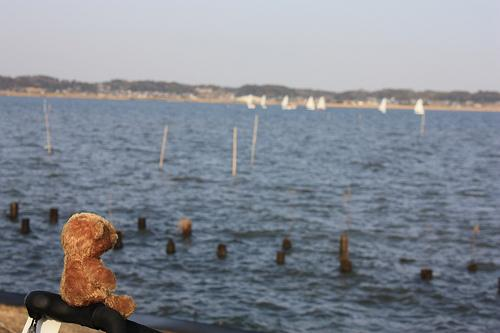Analyze the interaction between the teddy bear and its surroundings. The teddy bear is observing the water and sailboats, likely enjoying the serene and peaceful atmosphere while sitting securely on the bike handle. List the elements related to nature present in this image and explain their positions. There are row of trees beyond the beach located in the top-left region, mountains behind the water in the top-center region, and ripples in the water positioned in the center-right part of the image. What kind of boats are visible in the image, and whereabouts are they located? White sailboats are on the water in the top-right area of the image. Conduct a sentiment analysis of the image and describe the atmosphere. The image evokes a positive sentiment due to the peaceful setting of boats in the water, beautiful nature elements, and a cute teddy bear enjoying the view. Point out the object with the smallest size and describe its position. The smallest object is a small area of sandy beach at the bottom-left corner of the image. Count the number of pieces of wood sticking up from the water. There are 12 pieces of wood sticking up from the water. Provide a short description of the weather and overall atmosphere of the image. It is sunny outside with a hazy sky, mildly rough water, and clear blue-dark water, creating a peaceful and serene atmosphere. How many wooden poles are in the water and where are they located? There are wooden pegs and poles, totaling to 25 in the water, scattered throughout the image, mainly at the left and center regions. Identify the main object in the image and explain its position and color. A brown teddy bear is sitting on a bike handle at the left-top corner of the image, gazing toward the water. Notice the man wearing a bright green swimsuit and sunglasses while walking near the water's edge. This instruction describes a person (man) who is not mentioned in the list of objects, and the person is wearing distinctive clothing (bright green swimsuit, sunglasses) that also do not appear in the object list. Therefore, this instruction is misleading. Could you please point out the dolphins playfully leaping out of the water towards the left side of the image? This instruction uses an interrogative sentence and seeks information about dolphins, which are not mentioned in the list of objects in the image. Thus, the instruction is misleading. Can anyone observe the flock of seagulls hovering near a tourist who's attempting to feed them in the scene? This instruction uses an interrogative sentence form and brings up objects (flock of seagulls, tourist) not mentioned in the list of objects in the image. Consequently, it's misleading for viewers. Can you spot the vibrant pink seashell along the shoreline in the image? This instruction introduces a specific color (vibrant pink) and an object (seashell) that is not mentioned in the list of objects in the image. Therefore, it would be misleading for a viewer. It is interesting to note the intricate sandcastle built by children on the right-hand side of the small sandy beach area. This statement brings up an object (intricate sandcastle) and additional themes (built by children) which are not mentioned in the image's list of objects. So, this instruction is misleading. I wonder if you're able to find at least three colorful beach umbrellas scattered around the beach area. This instruction uses an interrogative sentence form and refers to "colorful beach umbrellas." There's no mention of any umbrella, let alone three of them or their colors, in the image's object list, making this instruction misleading. 